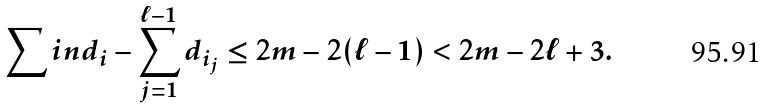<formula> <loc_0><loc_0><loc_500><loc_500>\sum i n d _ { i } - \sum _ { j = 1 } ^ { \ell - 1 } d _ { i _ { j } } \leq 2 m - 2 ( \ell - 1 ) < 2 m - 2 \ell + 3 .</formula> 